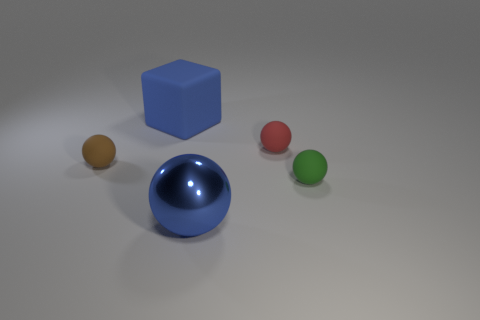The rubber object that is in front of the red ball and on the right side of the large metallic thing is what color?
Give a very brief answer. Green. The thing in front of the tiny rubber thing that is in front of the brown matte object is made of what material?
Make the answer very short. Metal. The red thing that is the same shape as the small brown matte object is what size?
Give a very brief answer. Small. Do the large thing on the right side of the big blue block and the big matte block have the same color?
Ensure brevity in your answer.  Yes. Are there fewer tiny red rubber balls than blue things?
Your answer should be compact. Yes. What number of other objects are there of the same color as the big ball?
Your answer should be very brief. 1. Does the sphere that is on the left side of the large blue block have the same material as the blue cube?
Offer a terse response. Yes. There is a big blue thing in front of the tiny green matte sphere; what is it made of?
Make the answer very short. Metal. What is the size of the blue object behind the big blue object that is in front of the red sphere?
Your answer should be compact. Large. Is there a tiny red object made of the same material as the large blue block?
Your answer should be compact. Yes. 